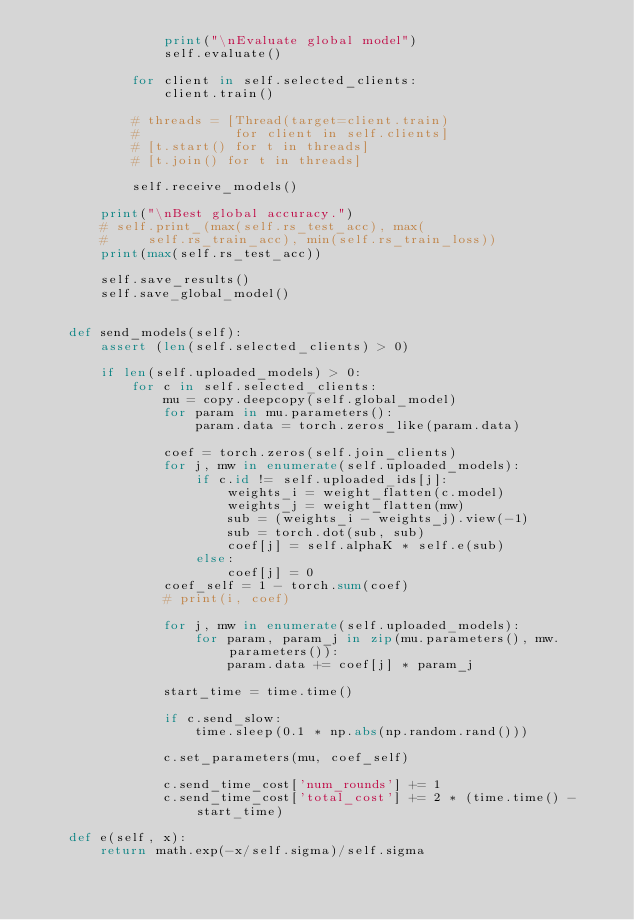Convert code to text. <code><loc_0><loc_0><loc_500><loc_500><_Python_>                print("\nEvaluate global model")
                self.evaluate()

            for client in self.selected_clients:
                client.train()

            # threads = [Thread(target=client.train)
            #            for client in self.clients]
            # [t.start() for t in threads]
            # [t.join() for t in threads]

            self.receive_models()

        print("\nBest global accuracy.")
        # self.print_(max(self.rs_test_acc), max(
        #     self.rs_train_acc), min(self.rs_train_loss))
        print(max(self.rs_test_acc))

        self.save_results()
        self.save_global_model()


    def send_models(self):
        assert (len(self.selected_clients) > 0)

        if len(self.uploaded_models) > 0:
            for c in self.selected_clients:
                mu = copy.deepcopy(self.global_model)
                for param in mu.parameters():
                    param.data = torch.zeros_like(param.data)

                coef = torch.zeros(self.join_clients)
                for j, mw in enumerate(self.uploaded_models):
                    if c.id != self.uploaded_ids[j]:
                        weights_i = weight_flatten(c.model)
                        weights_j = weight_flatten(mw)
                        sub = (weights_i - weights_j).view(-1)
                        sub = torch.dot(sub, sub)
                        coef[j] = self.alphaK * self.e(sub)
                    else:
                        coef[j] = 0
                coef_self = 1 - torch.sum(coef)
                # print(i, coef)

                for j, mw in enumerate(self.uploaded_models):
                    for param, param_j in zip(mu.parameters(), mw.parameters()):
                        param.data += coef[j] * param_j

                start_time = time.time()

                if c.send_slow:
                    time.sleep(0.1 * np.abs(np.random.rand()))

                c.set_parameters(mu, coef_self)

                c.send_time_cost['num_rounds'] += 1
                c.send_time_cost['total_cost'] += 2 * (time.time() - start_time)

    def e(self, x):
        return math.exp(-x/self.sigma)/self.sigma
</code> 